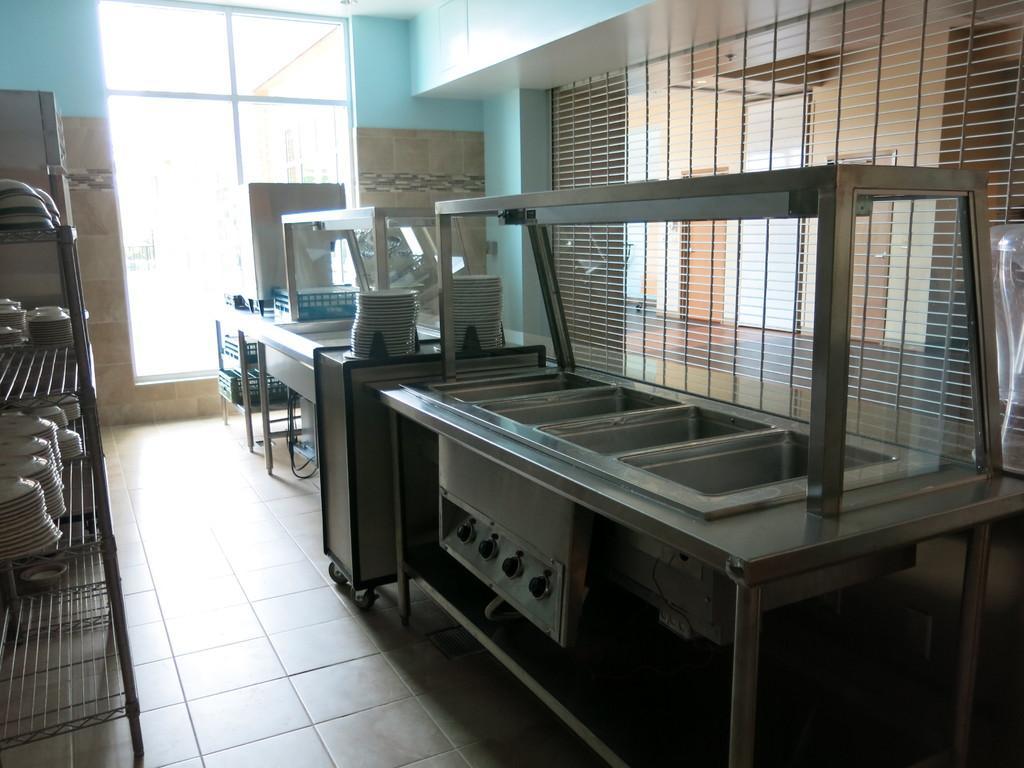Could you give a brief overview of what you see in this image? In the picture we can see a dish washer with switches to the desk and besides to it, we can see a table and plates on it which are white in color and we can also see some racks and plates in it and to the floor we can see the tiles and in the background we can see a wall with a glass window. 